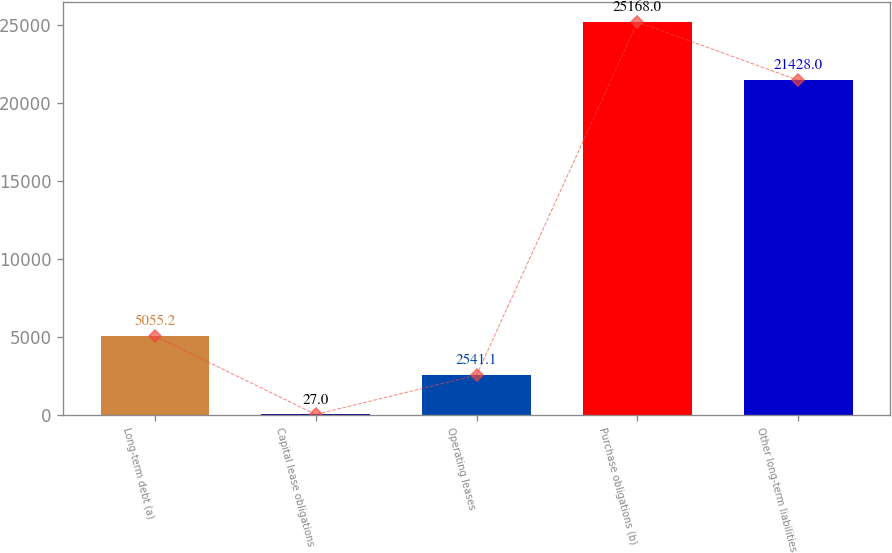Convert chart. <chart><loc_0><loc_0><loc_500><loc_500><bar_chart><fcel>Long-term debt (a)<fcel>Capital lease obligations<fcel>Operating leases<fcel>Purchase obligations (b)<fcel>Other long-term liabilities<nl><fcel>5055.2<fcel>27<fcel>2541.1<fcel>25168<fcel>21428<nl></chart> 